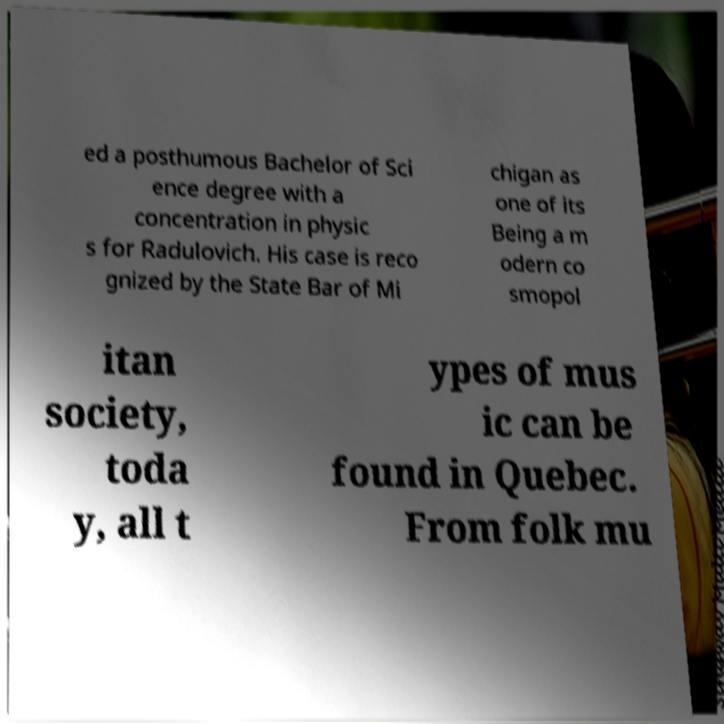Can you accurately transcribe the text from the provided image for me? ed a posthumous Bachelor of Sci ence degree with a concentration in physic s for Radulovich. His case is reco gnized by the State Bar of Mi chigan as one of its Being a m odern co smopol itan society, toda y, all t ypes of mus ic can be found in Quebec. From folk mu 